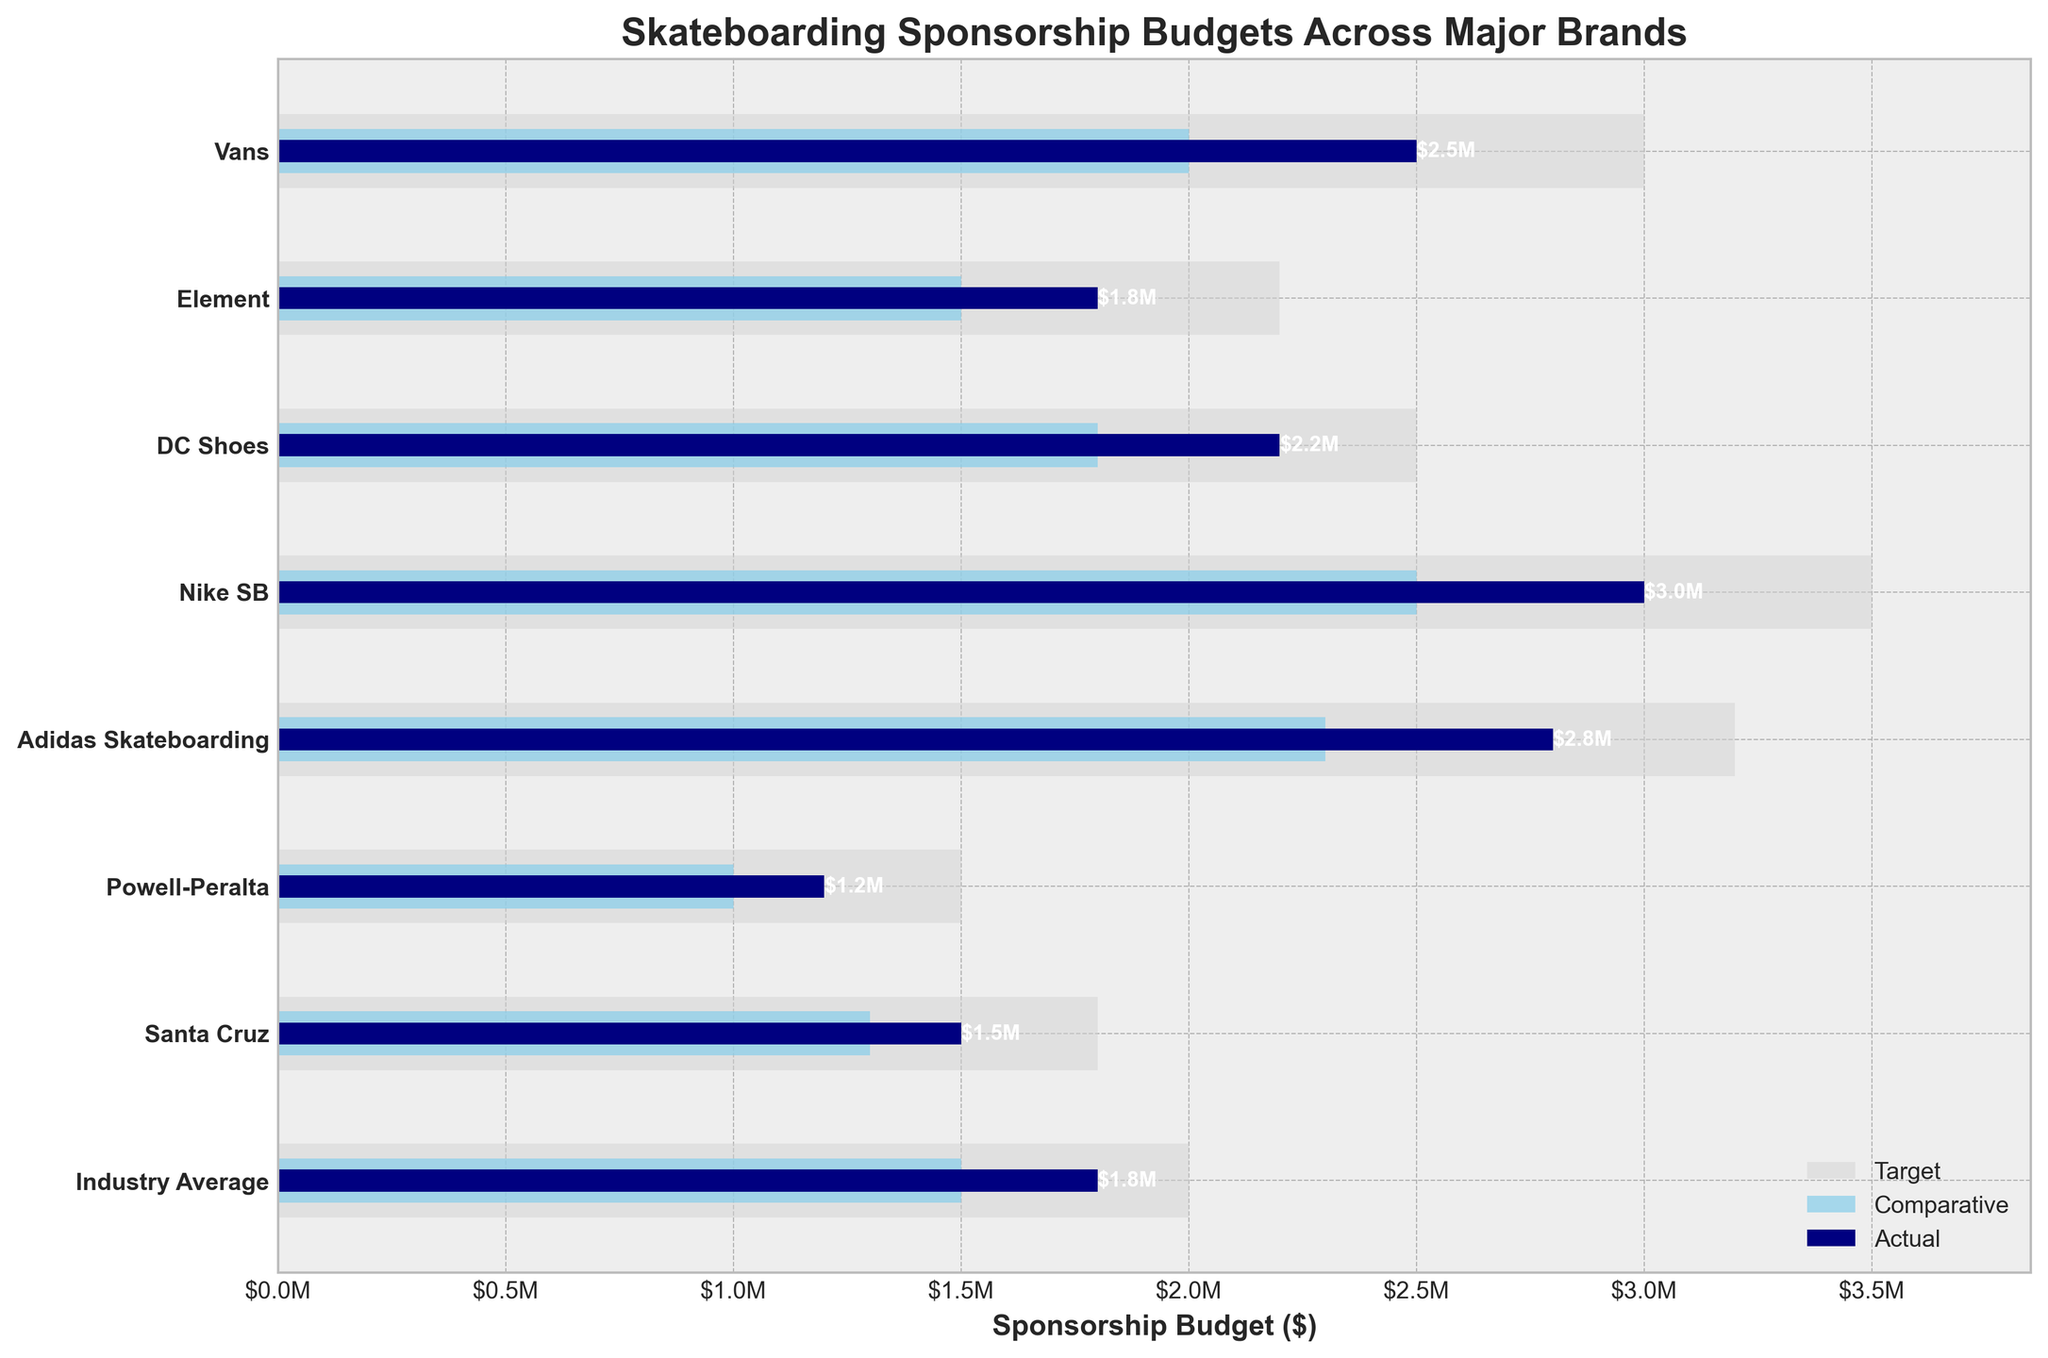What is the title of the figure? The title is usually displayed at the top of the figure. It explains what the chart is about.
Answer: Skateboarding Sponsorship Budgets Across Major Brands Which brand has the highest actual sponsorship budget? To find this, look at which actual bar (the darkest one) extends furthest to the right on the horizontal axis.
Answer: Nike SB What are the comparative and target budgets for Vans? Look for the lengths of the sky blue and light gray bars for Vans, corresponding to comparative and target budgets. The comparative is 2 million, and the target is 3 million dollars.
Answer: $2,000,000 (comparative), $3,000,000 (target) How much higher is the actual budget of Nike SB compared to the industry average? Subtract the actual budget of the industry average from that of Nike SB. Actual for Nike SB is 3 million, and for industry average is 1.8 million dollars.
Answer: $1,200,000 Which brand's actual budget is the closest to the industry average? Compare the actual budget of each brand to the industry average and find the smallest difference. Powell-Peralta's actual budget is 1.2 million dollars, which is closest to the industry average of 1.8 million dollars.
Answer: Powell-Peralta Are there any brands that did not meet their target sponsorship budget? Compare the actual budget bars (dark blue) with the target budget bars (light gray) for each brand. If the actual bar is shorter, that brand did not meet the target.
Answer: All brands did not meet their target budgets What is the difference between Adidas Skateboarding’s target and actual budgets? Subtract the actual budget of Adidas Skateboarding from their target budget, which are 3.2 million and 2.8 million dollars respectively.
Answer: $400,000 Which brand has the smallest comparative budget? Look at the shortest sky blue bar among the brands. Powell-Peralta has the smallest comparative budget at 1 million dollars.
Answer: Powell-Peralta How does Element’s actual budget compare to DC Shoes? Compare the lengths of the dark blue bars for both brands. Element's actual budget (1.8 million dollars) is lower than DC Shoes’ (2.2 million dollars).
Answer: Element is $400,000 less What is the industry average target budget? Check the target budget bar for the Industry Average label.
Answer: $2,000,000 